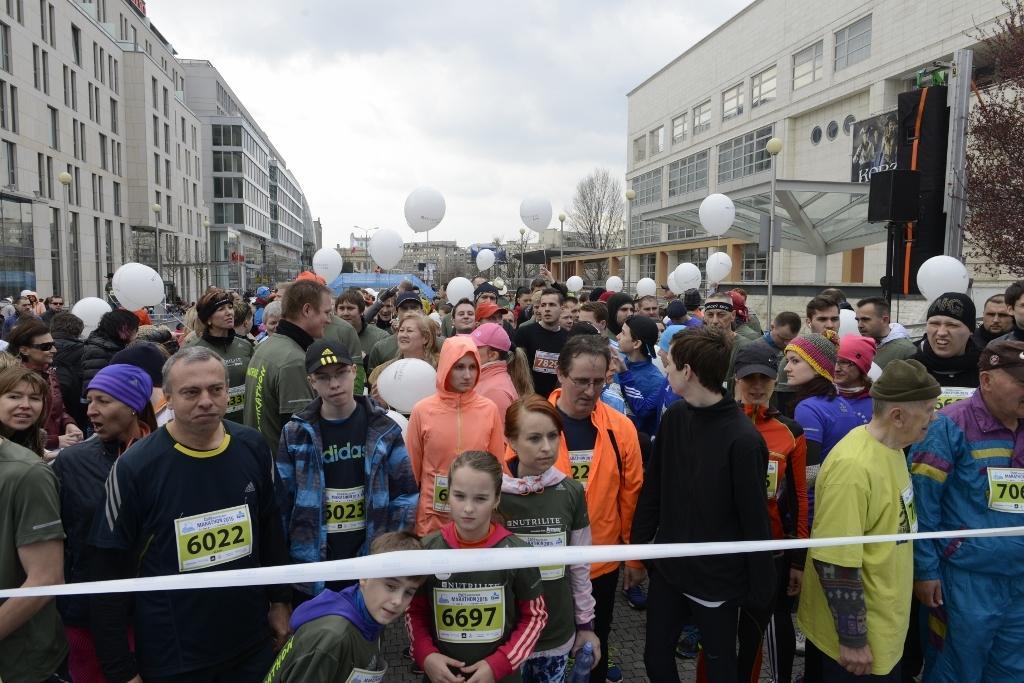Describe this image in one or two sentences. In this image, there are a few people, balloons, buildings, trees and poles. We can also see a white colored ribbon and the sky with clouds. We can also see a black colored object. 